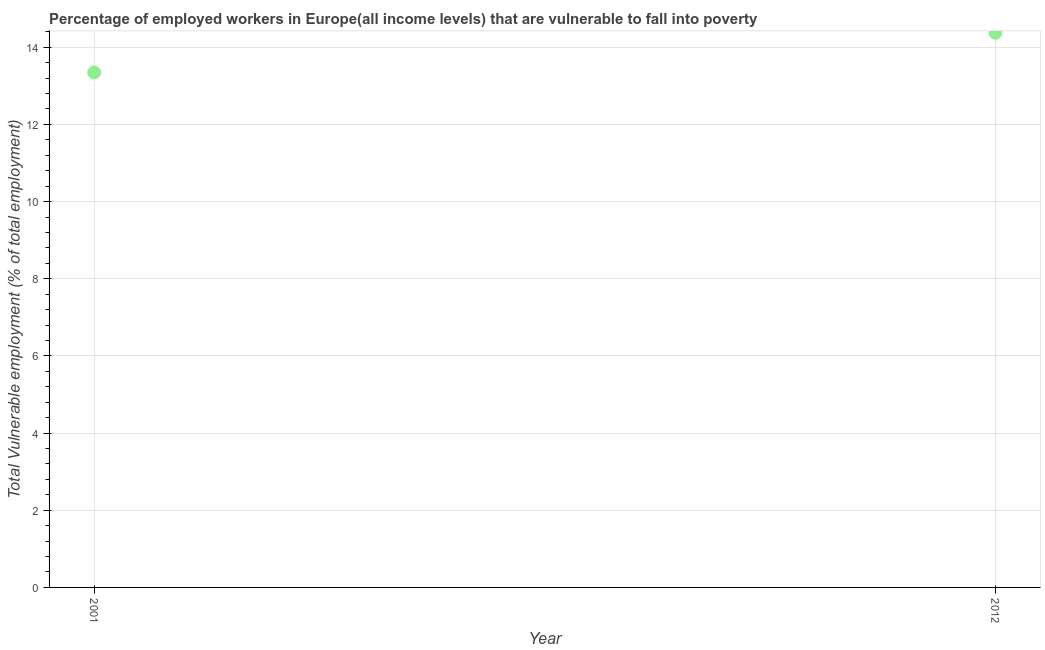What is the total vulnerable employment in 2001?
Provide a short and direct response. 13.35. Across all years, what is the maximum total vulnerable employment?
Your answer should be compact. 14.37. Across all years, what is the minimum total vulnerable employment?
Your answer should be very brief. 13.35. In which year was the total vulnerable employment minimum?
Give a very brief answer. 2001. What is the sum of the total vulnerable employment?
Make the answer very short. 27.72. What is the difference between the total vulnerable employment in 2001 and 2012?
Provide a succinct answer. -1.03. What is the average total vulnerable employment per year?
Keep it short and to the point. 13.86. What is the median total vulnerable employment?
Keep it short and to the point. 13.86. In how many years, is the total vulnerable employment greater than 5.2 %?
Your answer should be compact. 2. What is the ratio of the total vulnerable employment in 2001 to that in 2012?
Keep it short and to the point. 0.93. Is the total vulnerable employment in 2001 less than that in 2012?
Your answer should be compact. Yes. How many dotlines are there?
Your answer should be compact. 1. How many years are there in the graph?
Provide a short and direct response. 2. Does the graph contain grids?
Keep it short and to the point. Yes. What is the title of the graph?
Make the answer very short. Percentage of employed workers in Europe(all income levels) that are vulnerable to fall into poverty. What is the label or title of the Y-axis?
Your answer should be very brief. Total Vulnerable employment (% of total employment). What is the Total Vulnerable employment (% of total employment) in 2001?
Your answer should be very brief. 13.35. What is the Total Vulnerable employment (% of total employment) in 2012?
Ensure brevity in your answer.  14.37. What is the difference between the Total Vulnerable employment (% of total employment) in 2001 and 2012?
Give a very brief answer. -1.03. What is the ratio of the Total Vulnerable employment (% of total employment) in 2001 to that in 2012?
Provide a short and direct response. 0.93. 